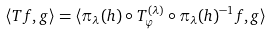<formula> <loc_0><loc_0><loc_500><loc_500>\langle T f , g \rangle = \langle \pi _ { \lambda } ( h ) \circ T ^ { ( \lambda ) } _ { \varphi } \circ \pi _ { \lambda } ( h ) ^ { - 1 } f , g \rangle</formula> 